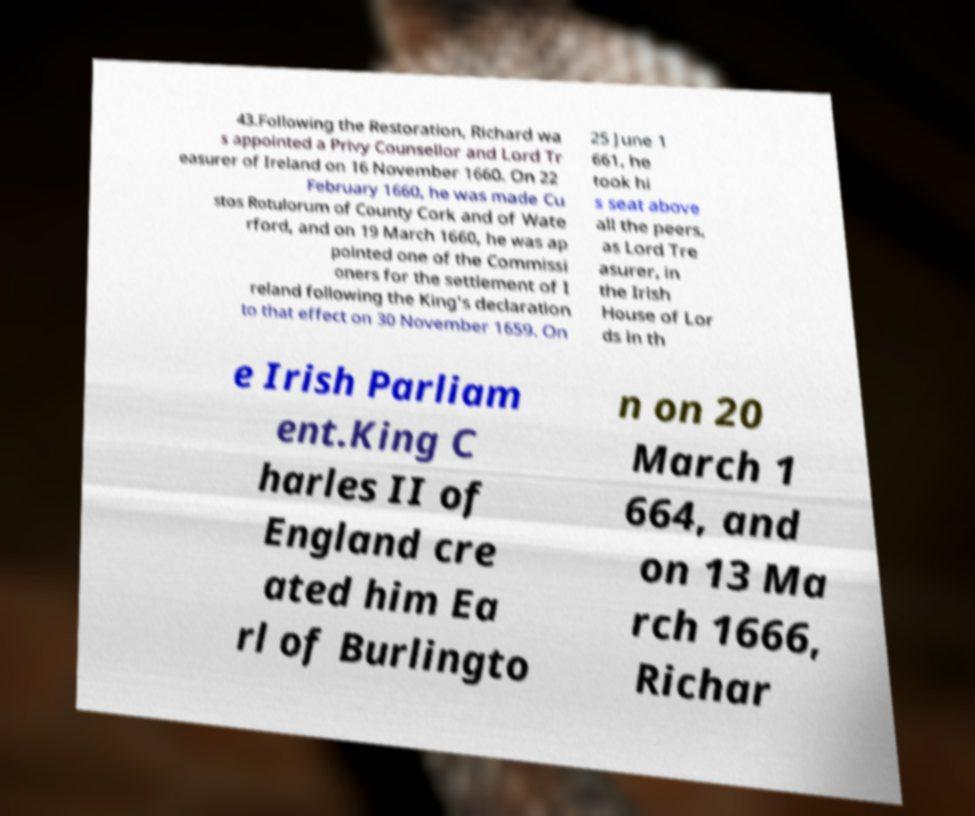There's text embedded in this image that I need extracted. Can you transcribe it verbatim? 43.Following the Restoration, Richard wa s appointed a Privy Counsellor and Lord Tr easurer of Ireland on 16 November 1660. On 22 February 1660, he was made Cu stos Rotulorum of County Cork and of Wate rford, and on 19 March 1660, he was ap pointed one of the Commissi oners for the settlement of I reland following the King's declaration to that effect on 30 November 1659. On 25 June 1 661, he took hi s seat above all the peers, as Lord Tre asurer, in the Irish House of Lor ds in th e Irish Parliam ent.King C harles II of England cre ated him Ea rl of Burlingto n on 20 March 1 664, and on 13 Ma rch 1666, Richar 